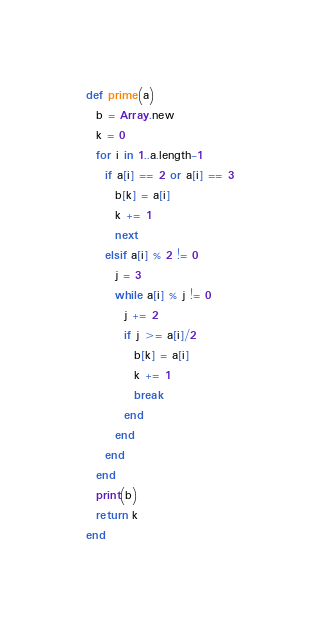Convert code to text. <code><loc_0><loc_0><loc_500><loc_500><_Ruby_>def prime(a)
  b = Array.new
  k = 0
  for i in 1..a.length-1
    if a[i] == 2 or a[i] == 3
      b[k] = a[i]
      k += 1
      next
    elsif a[i] % 2 != 0
      j = 3
      while a[i] % j != 0
        j += 2
        if j >= a[i]/2
          b[k] = a[i]
          k += 1
          break
        end
      end
    end
  end
  print(b)
  return k
end

</code> 